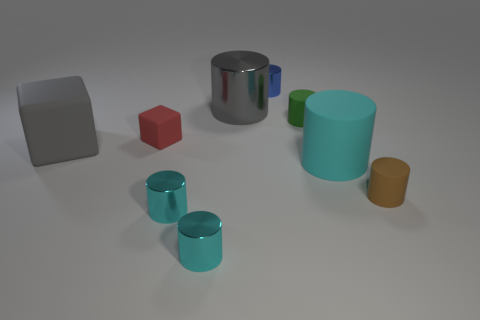Subtract all small cyan cylinders. How many cylinders are left? 5 Subtract all purple cubes. How many cyan cylinders are left? 3 Subtract 1 cylinders. How many cylinders are left? 6 Subtract all gray cylinders. How many cylinders are left? 6 Add 2 tiny brown rubber cylinders. How many tiny brown rubber cylinders are left? 3 Add 7 blue shiny things. How many blue shiny things exist? 8 Subtract 1 gray cylinders. How many objects are left? 8 Subtract all cylinders. How many objects are left? 2 Subtract all cyan blocks. Subtract all blue cylinders. How many blocks are left? 2 Subtract all big metallic cylinders. Subtract all green rubber cylinders. How many objects are left? 7 